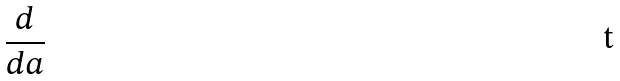Convert formula to latex. <formula><loc_0><loc_0><loc_500><loc_500>\frac { d } { d a }</formula> 